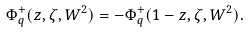<formula> <loc_0><loc_0><loc_500><loc_500>\Phi ^ { + } _ { q } ( z , \zeta , W ^ { 2 } ) = - \Phi ^ { + } _ { q } ( 1 - z , \zeta , W ^ { 2 } ) .</formula> 